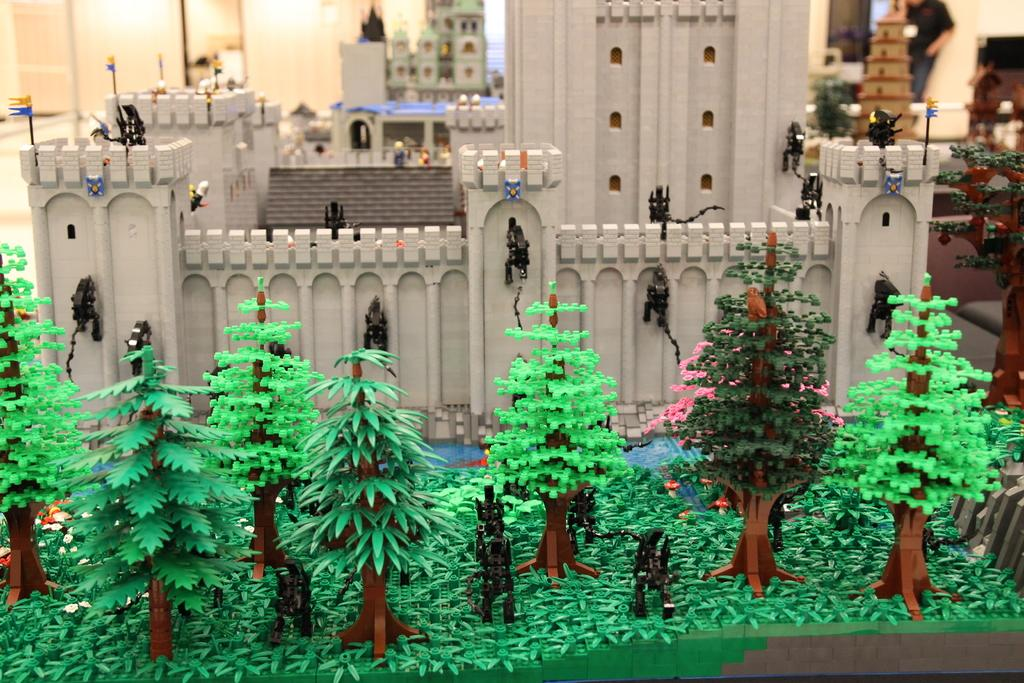What type of structures can be seen in the image? There are buildings in the image. What type of barrier is present in the image? There is a fencing wall in the image. What type of vegetation is visible in the image? There are trees and plants in the image. What other objects can be seen in the image? There are other objects in the image, but their specific details are not mentioned in the facts. What is visible in the background of the image? There is a wall, lights, and a person in the background of the image. What type of sweater is the person wearing in the image? There is no information about a sweater or the person's clothing in the provided facts, so we cannot determine what type of sweater they might be wearing. Is there a carriage visible in the image? No, there is no mention of a carriage in the provided facts, so it is not present in the image. 